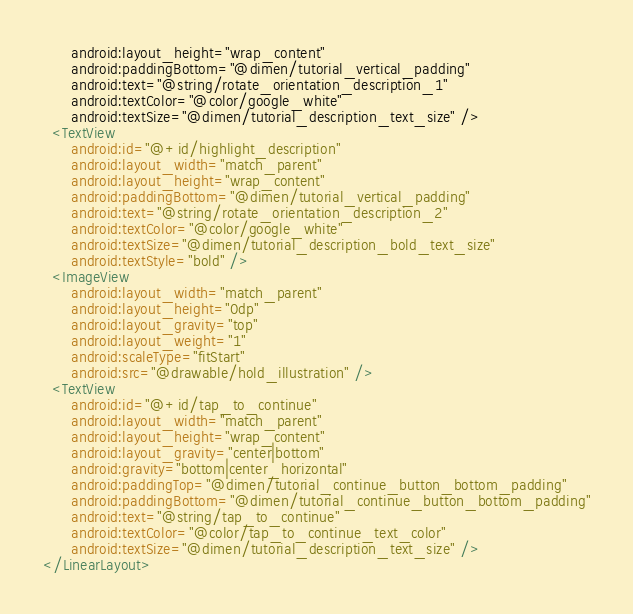Convert code to text. <code><loc_0><loc_0><loc_500><loc_500><_XML_>      android:layout_height="wrap_content"
      android:paddingBottom="@dimen/tutorial_vertical_padding"
      android:text="@string/rotate_orientation_description_1"
      android:textColor="@color/google_white"
      android:textSize="@dimen/tutorial_description_text_size" />
  <TextView
      android:id="@+id/highlight_description"
      android:layout_width="match_parent"
      android:layout_height="wrap_content"
      android:paddingBottom="@dimen/tutorial_vertical_padding"
      android:text="@string/rotate_orientation_description_2"
      android:textColor="@color/google_white"
      android:textSize="@dimen/tutorial_description_bold_text_size"
      android:textStyle="bold" />
  <ImageView
      android:layout_width="match_parent"
      android:layout_height="0dp"
      android:layout_gravity="top"
      android:layout_weight="1"
      android:scaleType="fitStart"
      android:src="@drawable/hold_illustration" />
  <TextView
      android:id="@+id/tap_to_continue"
      android:layout_width="match_parent"
      android:layout_height="wrap_content"
      android:layout_gravity="center|bottom"
      android:gravity="bottom|center_horizontal"
      android:paddingTop="@dimen/tutorial_continue_button_bottom_padding"
      android:paddingBottom="@dimen/tutorial_continue_button_bottom_padding"
      android:text="@string/tap_to_continue"
      android:textColor="@color/tap_to_continue_text_color"
      android:textSize="@dimen/tutorial_description_text_size" />
</LinearLayout></code> 